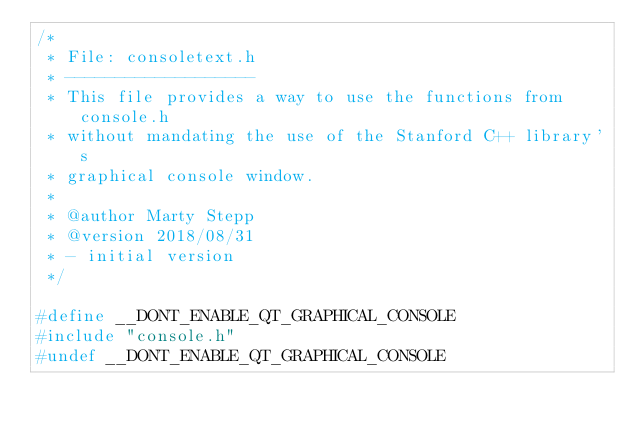<code> <loc_0><loc_0><loc_500><loc_500><_C_>/*
 * File: consoletext.h
 * -------------------
 * This file provides a way to use the functions from console.h
 * without mandating the use of the Stanford C++ library's
 * graphical console window.
 * 
 * @author Marty Stepp
 * @version 2018/08/31
 * - initial version
 */

#define __DONT_ENABLE_QT_GRAPHICAL_CONSOLE
#include "console.h"
#undef __DONT_ENABLE_QT_GRAPHICAL_CONSOLE
</code> 